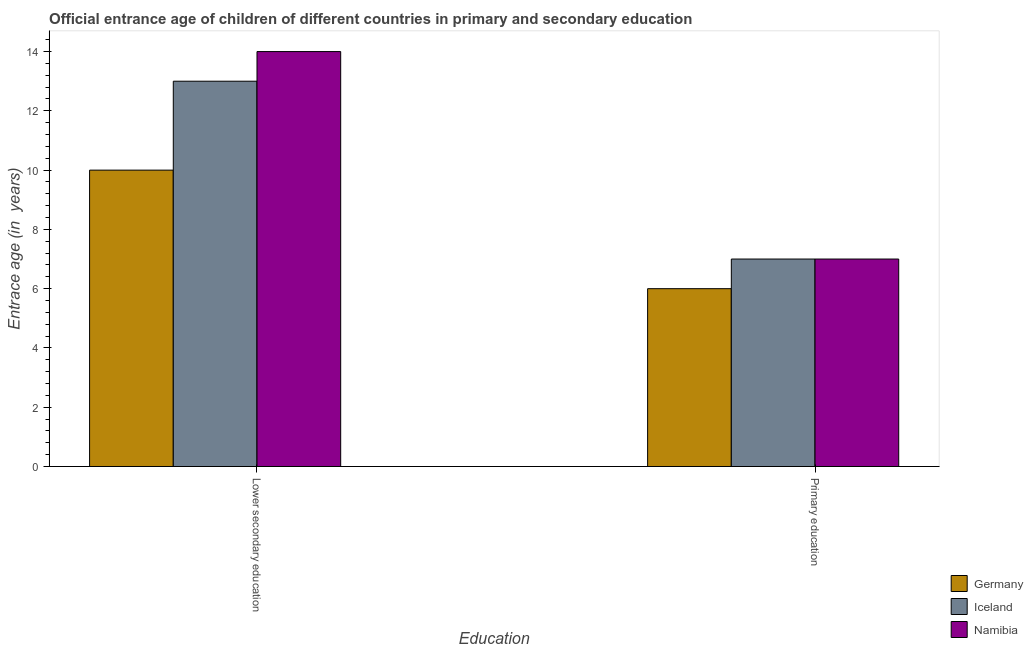How many different coloured bars are there?
Provide a short and direct response. 3. How many groups of bars are there?
Offer a very short reply. 2. How many bars are there on the 1st tick from the right?
Keep it short and to the point. 3. What is the label of the 1st group of bars from the left?
Offer a terse response. Lower secondary education. What is the entrance age of chiildren in primary education in Namibia?
Offer a terse response. 7. Across all countries, what is the maximum entrance age of chiildren in primary education?
Offer a terse response. 7. What is the total entrance age of chiildren in primary education in the graph?
Keep it short and to the point. 20. What is the difference between the entrance age of chiildren in primary education in Namibia and that in Germany?
Offer a terse response. 1. What is the difference between the entrance age of children in lower secondary education in Namibia and the entrance age of chiildren in primary education in Germany?
Your response must be concise. 8. What is the average entrance age of chiildren in primary education per country?
Your answer should be very brief. 6.67. What is the difference between the entrance age of children in lower secondary education and entrance age of chiildren in primary education in Iceland?
Offer a terse response. 6. Is the entrance age of children in lower secondary education in Iceland less than that in Germany?
Offer a terse response. No. What does the 3rd bar from the left in Lower secondary education represents?
Ensure brevity in your answer.  Namibia. Are all the bars in the graph horizontal?
Give a very brief answer. No. How many countries are there in the graph?
Your answer should be very brief. 3. Does the graph contain grids?
Keep it short and to the point. No. Where does the legend appear in the graph?
Provide a succinct answer. Bottom right. How many legend labels are there?
Provide a succinct answer. 3. What is the title of the graph?
Make the answer very short. Official entrance age of children of different countries in primary and secondary education. What is the label or title of the X-axis?
Keep it short and to the point. Education. What is the label or title of the Y-axis?
Your answer should be very brief. Entrace age (in  years). What is the Entrace age (in  years) in Iceland in Lower secondary education?
Make the answer very short. 13. What is the Entrace age (in  years) in Germany in Primary education?
Give a very brief answer. 6. What is the Entrace age (in  years) in Iceland in Primary education?
Provide a short and direct response. 7. What is the Entrace age (in  years) of Namibia in Primary education?
Offer a very short reply. 7. Across all Education, what is the maximum Entrace age (in  years) of Namibia?
Ensure brevity in your answer.  14. Across all Education, what is the minimum Entrace age (in  years) of Germany?
Your response must be concise. 6. Across all Education, what is the minimum Entrace age (in  years) in Namibia?
Your answer should be compact. 7. What is the total Entrace age (in  years) of Germany in the graph?
Make the answer very short. 16. What is the difference between the Entrace age (in  years) in Iceland in Lower secondary education and that in Primary education?
Keep it short and to the point. 6. What is the difference between the Entrace age (in  years) of Germany in Lower secondary education and the Entrace age (in  years) of Namibia in Primary education?
Your answer should be compact. 3. What is the difference between the Entrace age (in  years) in Germany and Entrace age (in  years) in Namibia in Lower secondary education?
Your response must be concise. -4. What is the ratio of the Entrace age (in  years) of Germany in Lower secondary education to that in Primary education?
Keep it short and to the point. 1.67. What is the ratio of the Entrace age (in  years) of Iceland in Lower secondary education to that in Primary education?
Your response must be concise. 1.86. What is the ratio of the Entrace age (in  years) of Namibia in Lower secondary education to that in Primary education?
Keep it short and to the point. 2. What is the difference between the highest and the second highest Entrace age (in  years) in Germany?
Keep it short and to the point. 4. What is the difference between the highest and the second highest Entrace age (in  years) of Iceland?
Your answer should be compact. 6. What is the difference between the highest and the lowest Entrace age (in  years) of Iceland?
Keep it short and to the point. 6. 